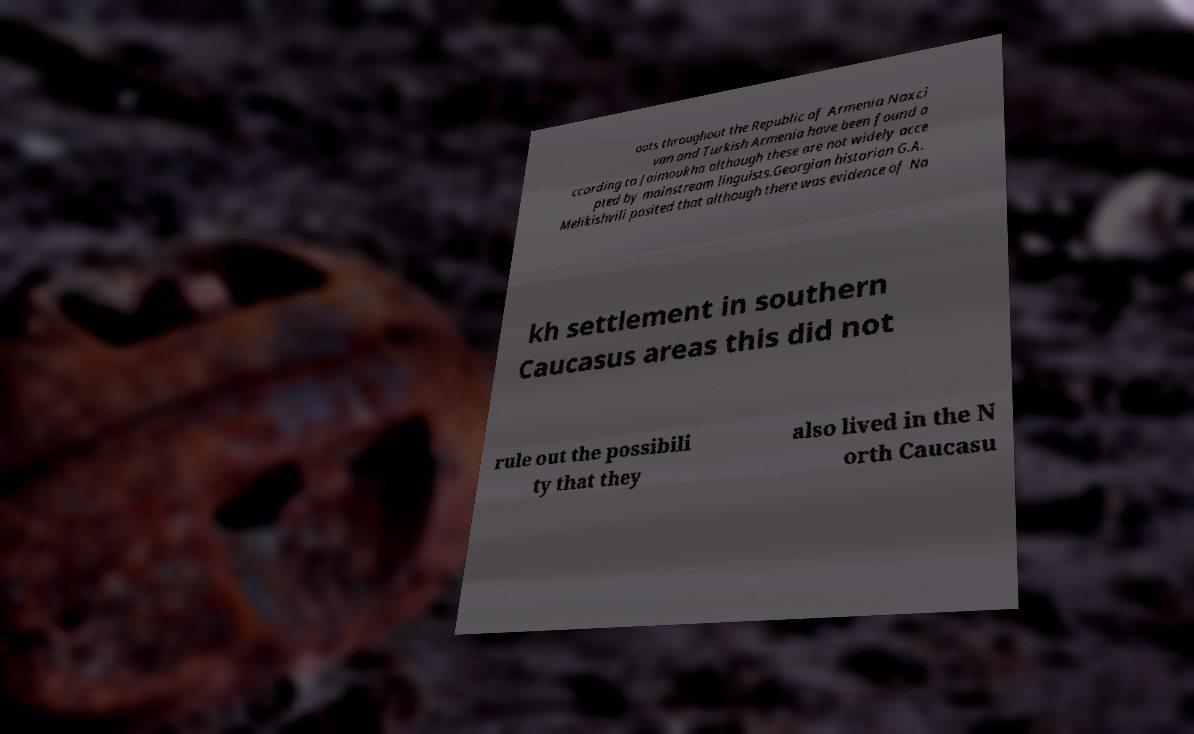I need the written content from this picture converted into text. Can you do that? oots throughout the Republic of Armenia Naxci van and Turkish Armenia have been found a ccording to Jaimoukha although these are not widely acce pted by mainstream linguists.Georgian historian G.A. Melikishvili posited that although there was evidence of Na kh settlement in southern Caucasus areas this did not rule out the possibili ty that they also lived in the N orth Caucasu 